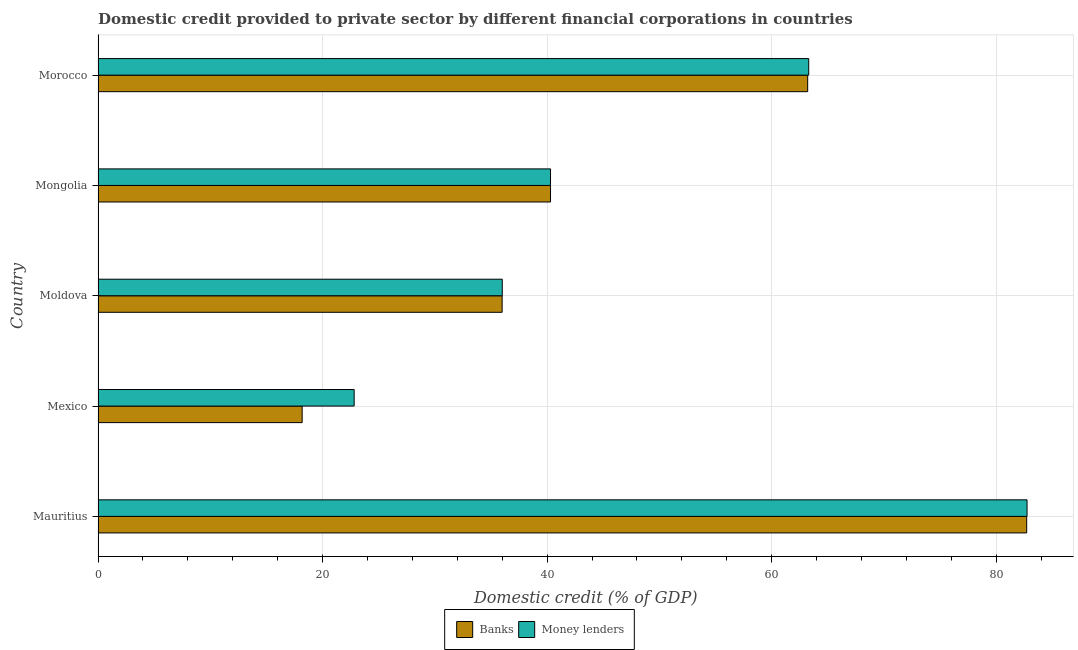How many groups of bars are there?
Give a very brief answer. 5. Are the number of bars per tick equal to the number of legend labels?
Ensure brevity in your answer.  Yes. How many bars are there on the 2nd tick from the top?
Your response must be concise. 2. How many bars are there on the 2nd tick from the bottom?
Your response must be concise. 2. What is the label of the 3rd group of bars from the top?
Your answer should be compact. Moldova. What is the domestic credit provided by banks in Morocco?
Keep it short and to the point. 63.2. Across all countries, what is the maximum domestic credit provided by money lenders?
Make the answer very short. 82.74. Across all countries, what is the minimum domestic credit provided by money lenders?
Make the answer very short. 22.81. In which country was the domestic credit provided by money lenders maximum?
Offer a terse response. Mauritius. In which country was the domestic credit provided by money lenders minimum?
Your answer should be compact. Mexico. What is the total domestic credit provided by money lenders in the graph?
Your answer should be very brief. 245.16. What is the difference between the domestic credit provided by money lenders in Moldova and that in Morocco?
Offer a very short reply. -27.3. What is the difference between the domestic credit provided by money lenders in Morocco and the domestic credit provided by banks in Mauritius?
Offer a very short reply. -19.41. What is the average domestic credit provided by money lenders per country?
Provide a short and direct response. 49.03. What is the difference between the domestic credit provided by money lenders and domestic credit provided by banks in Moldova?
Ensure brevity in your answer.  0.01. In how many countries, is the domestic credit provided by money lenders greater than 16 %?
Provide a short and direct response. 5. What is the ratio of the domestic credit provided by banks in Mauritius to that in Moldova?
Your answer should be compact. 2.3. Is the domestic credit provided by banks in Moldova less than that in Mongolia?
Your answer should be compact. Yes. What is the difference between the highest and the second highest domestic credit provided by banks?
Your response must be concise. 19.51. What is the difference between the highest and the lowest domestic credit provided by money lenders?
Make the answer very short. 59.93. In how many countries, is the domestic credit provided by money lenders greater than the average domestic credit provided by money lenders taken over all countries?
Give a very brief answer. 2. Is the sum of the domestic credit provided by banks in Moldova and Mongolia greater than the maximum domestic credit provided by money lenders across all countries?
Give a very brief answer. No. What does the 2nd bar from the top in Morocco represents?
Keep it short and to the point. Banks. What does the 1st bar from the bottom in Mauritius represents?
Your answer should be very brief. Banks. How many bars are there?
Offer a very short reply. 10. Are the values on the major ticks of X-axis written in scientific E-notation?
Your answer should be compact. No. Does the graph contain any zero values?
Offer a terse response. No. Does the graph contain grids?
Ensure brevity in your answer.  Yes. Where does the legend appear in the graph?
Your response must be concise. Bottom center. What is the title of the graph?
Provide a succinct answer. Domestic credit provided to private sector by different financial corporations in countries. What is the label or title of the X-axis?
Offer a very short reply. Domestic credit (% of GDP). What is the Domestic credit (% of GDP) of Banks in Mauritius?
Provide a short and direct response. 82.71. What is the Domestic credit (% of GDP) of Money lenders in Mauritius?
Ensure brevity in your answer.  82.74. What is the Domestic credit (% of GDP) in Banks in Mexico?
Offer a terse response. 18.18. What is the Domestic credit (% of GDP) of Money lenders in Mexico?
Your response must be concise. 22.81. What is the Domestic credit (% of GDP) in Banks in Moldova?
Your response must be concise. 35.99. What is the Domestic credit (% of GDP) in Money lenders in Moldova?
Your answer should be very brief. 36. What is the Domestic credit (% of GDP) in Banks in Mongolia?
Give a very brief answer. 40.3. What is the Domestic credit (% of GDP) in Money lenders in Mongolia?
Provide a succinct answer. 40.3. What is the Domestic credit (% of GDP) of Banks in Morocco?
Your response must be concise. 63.2. What is the Domestic credit (% of GDP) in Money lenders in Morocco?
Offer a very short reply. 63.3. Across all countries, what is the maximum Domestic credit (% of GDP) of Banks?
Ensure brevity in your answer.  82.71. Across all countries, what is the maximum Domestic credit (% of GDP) of Money lenders?
Make the answer very short. 82.74. Across all countries, what is the minimum Domestic credit (% of GDP) of Banks?
Your response must be concise. 18.18. Across all countries, what is the minimum Domestic credit (% of GDP) of Money lenders?
Keep it short and to the point. 22.81. What is the total Domestic credit (% of GDP) in Banks in the graph?
Ensure brevity in your answer.  240.39. What is the total Domestic credit (% of GDP) of Money lenders in the graph?
Keep it short and to the point. 245.16. What is the difference between the Domestic credit (% of GDP) in Banks in Mauritius and that in Mexico?
Ensure brevity in your answer.  64.53. What is the difference between the Domestic credit (% of GDP) in Money lenders in Mauritius and that in Mexico?
Give a very brief answer. 59.93. What is the difference between the Domestic credit (% of GDP) of Banks in Mauritius and that in Moldova?
Provide a succinct answer. 46.72. What is the difference between the Domestic credit (% of GDP) in Money lenders in Mauritius and that in Moldova?
Give a very brief answer. 46.74. What is the difference between the Domestic credit (% of GDP) of Banks in Mauritius and that in Mongolia?
Your answer should be compact. 42.41. What is the difference between the Domestic credit (% of GDP) of Money lenders in Mauritius and that in Mongolia?
Give a very brief answer. 42.44. What is the difference between the Domestic credit (% of GDP) in Banks in Mauritius and that in Morocco?
Your response must be concise. 19.51. What is the difference between the Domestic credit (% of GDP) of Money lenders in Mauritius and that in Morocco?
Offer a terse response. 19.45. What is the difference between the Domestic credit (% of GDP) of Banks in Mexico and that in Moldova?
Keep it short and to the point. -17.81. What is the difference between the Domestic credit (% of GDP) in Money lenders in Mexico and that in Moldova?
Your answer should be compact. -13.19. What is the difference between the Domestic credit (% of GDP) in Banks in Mexico and that in Mongolia?
Offer a terse response. -22.12. What is the difference between the Domestic credit (% of GDP) of Money lenders in Mexico and that in Mongolia?
Your answer should be compact. -17.49. What is the difference between the Domestic credit (% of GDP) of Banks in Mexico and that in Morocco?
Your answer should be compact. -45.03. What is the difference between the Domestic credit (% of GDP) in Money lenders in Mexico and that in Morocco?
Provide a short and direct response. -40.49. What is the difference between the Domestic credit (% of GDP) in Banks in Moldova and that in Mongolia?
Offer a terse response. -4.31. What is the difference between the Domestic credit (% of GDP) of Money lenders in Moldova and that in Mongolia?
Your answer should be very brief. -4.3. What is the difference between the Domestic credit (% of GDP) in Banks in Moldova and that in Morocco?
Give a very brief answer. -27.21. What is the difference between the Domestic credit (% of GDP) of Money lenders in Moldova and that in Morocco?
Offer a terse response. -27.3. What is the difference between the Domestic credit (% of GDP) of Banks in Mongolia and that in Morocco?
Offer a terse response. -22.9. What is the difference between the Domestic credit (% of GDP) of Money lenders in Mongolia and that in Morocco?
Provide a succinct answer. -23. What is the difference between the Domestic credit (% of GDP) in Banks in Mauritius and the Domestic credit (% of GDP) in Money lenders in Mexico?
Ensure brevity in your answer.  59.9. What is the difference between the Domestic credit (% of GDP) of Banks in Mauritius and the Domestic credit (% of GDP) of Money lenders in Moldova?
Provide a short and direct response. 46.71. What is the difference between the Domestic credit (% of GDP) of Banks in Mauritius and the Domestic credit (% of GDP) of Money lenders in Mongolia?
Ensure brevity in your answer.  42.41. What is the difference between the Domestic credit (% of GDP) of Banks in Mauritius and the Domestic credit (% of GDP) of Money lenders in Morocco?
Offer a terse response. 19.41. What is the difference between the Domestic credit (% of GDP) in Banks in Mexico and the Domestic credit (% of GDP) in Money lenders in Moldova?
Make the answer very short. -17.82. What is the difference between the Domestic credit (% of GDP) of Banks in Mexico and the Domestic credit (% of GDP) of Money lenders in Mongolia?
Give a very brief answer. -22.12. What is the difference between the Domestic credit (% of GDP) in Banks in Mexico and the Domestic credit (% of GDP) in Money lenders in Morocco?
Give a very brief answer. -45.12. What is the difference between the Domestic credit (% of GDP) in Banks in Moldova and the Domestic credit (% of GDP) in Money lenders in Mongolia?
Ensure brevity in your answer.  -4.31. What is the difference between the Domestic credit (% of GDP) of Banks in Moldova and the Domestic credit (% of GDP) of Money lenders in Morocco?
Provide a succinct answer. -27.31. What is the difference between the Domestic credit (% of GDP) of Banks in Mongolia and the Domestic credit (% of GDP) of Money lenders in Morocco?
Provide a succinct answer. -23. What is the average Domestic credit (% of GDP) in Banks per country?
Offer a terse response. 48.08. What is the average Domestic credit (% of GDP) of Money lenders per country?
Provide a succinct answer. 49.03. What is the difference between the Domestic credit (% of GDP) of Banks and Domestic credit (% of GDP) of Money lenders in Mauritius?
Provide a short and direct response. -0.03. What is the difference between the Domestic credit (% of GDP) in Banks and Domestic credit (% of GDP) in Money lenders in Mexico?
Offer a very short reply. -4.63. What is the difference between the Domestic credit (% of GDP) in Banks and Domestic credit (% of GDP) in Money lenders in Moldova?
Provide a short and direct response. -0.01. What is the difference between the Domestic credit (% of GDP) in Banks and Domestic credit (% of GDP) in Money lenders in Morocco?
Provide a short and direct response. -0.09. What is the ratio of the Domestic credit (% of GDP) in Banks in Mauritius to that in Mexico?
Offer a terse response. 4.55. What is the ratio of the Domestic credit (% of GDP) in Money lenders in Mauritius to that in Mexico?
Your response must be concise. 3.63. What is the ratio of the Domestic credit (% of GDP) in Banks in Mauritius to that in Moldova?
Provide a succinct answer. 2.3. What is the ratio of the Domestic credit (% of GDP) of Money lenders in Mauritius to that in Moldova?
Offer a terse response. 2.3. What is the ratio of the Domestic credit (% of GDP) in Banks in Mauritius to that in Mongolia?
Provide a short and direct response. 2.05. What is the ratio of the Domestic credit (% of GDP) of Money lenders in Mauritius to that in Mongolia?
Your answer should be compact. 2.05. What is the ratio of the Domestic credit (% of GDP) in Banks in Mauritius to that in Morocco?
Your answer should be compact. 1.31. What is the ratio of the Domestic credit (% of GDP) in Money lenders in Mauritius to that in Morocco?
Ensure brevity in your answer.  1.31. What is the ratio of the Domestic credit (% of GDP) in Banks in Mexico to that in Moldova?
Your answer should be compact. 0.51. What is the ratio of the Domestic credit (% of GDP) in Money lenders in Mexico to that in Moldova?
Give a very brief answer. 0.63. What is the ratio of the Domestic credit (% of GDP) in Banks in Mexico to that in Mongolia?
Give a very brief answer. 0.45. What is the ratio of the Domestic credit (% of GDP) in Money lenders in Mexico to that in Mongolia?
Provide a succinct answer. 0.57. What is the ratio of the Domestic credit (% of GDP) of Banks in Mexico to that in Morocco?
Offer a very short reply. 0.29. What is the ratio of the Domestic credit (% of GDP) of Money lenders in Mexico to that in Morocco?
Provide a succinct answer. 0.36. What is the ratio of the Domestic credit (% of GDP) of Banks in Moldova to that in Mongolia?
Give a very brief answer. 0.89. What is the ratio of the Domestic credit (% of GDP) in Money lenders in Moldova to that in Mongolia?
Offer a terse response. 0.89. What is the ratio of the Domestic credit (% of GDP) of Banks in Moldova to that in Morocco?
Keep it short and to the point. 0.57. What is the ratio of the Domestic credit (% of GDP) in Money lenders in Moldova to that in Morocco?
Make the answer very short. 0.57. What is the ratio of the Domestic credit (% of GDP) of Banks in Mongolia to that in Morocco?
Provide a succinct answer. 0.64. What is the ratio of the Domestic credit (% of GDP) in Money lenders in Mongolia to that in Morocco?
Ensure brevity in your answer.  0.64. What is the difference between the highest and the second highest Domestic credit (% of GDP) of Banks?
Keep it short and to the point. 19.51. What is the difference between the highest and the second highest Domestic credit (% of GDP) in Money lenders?
Your response must be concise. 19.45. What is the difference between the highest and the lowest Domestic credit (% of GDP) in Banks?
Ensure brevity in your answer.  64.53. What is the difference between the highest and the lowest Domestic credit (% of GDP) in Money lenders?
Your response must be concise. 59.93. 